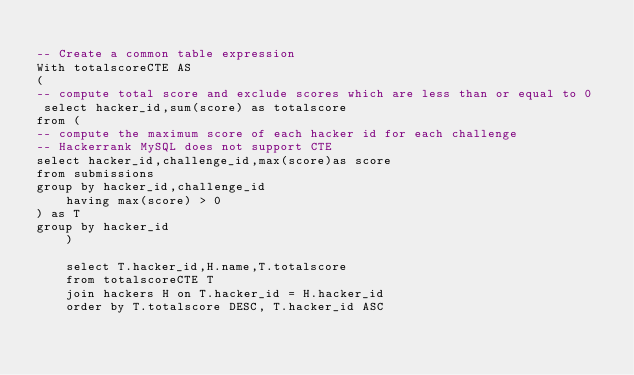<code> <loc_0><loc_0><loc_500><loc_500><_SQL_>
-- Create a common table expression
With totalscoreCTE AS 
(
-- compute total score and exclude scores which are less than or equal to 0    
 select hacker_id,sum(score) as totalscore
from (
-- compute the maximum score of each hacker id for each challenge
-- Hackerrank MySQL does not support CTE    
select hacker_id,challenge_id,max(score)as score
from submissions
group by hacker_id,challenge_id
    having max(score) > 0
) as T
group by hacker_id
    )
    
    select T.hacker_id,H.name,T.totalscore
    from totalscoreCTE T 
    join hackers H on T.hacker_id = H.hacker_id
    order by T.totalscore DESC, T.hacker_id ASC 
</code> 